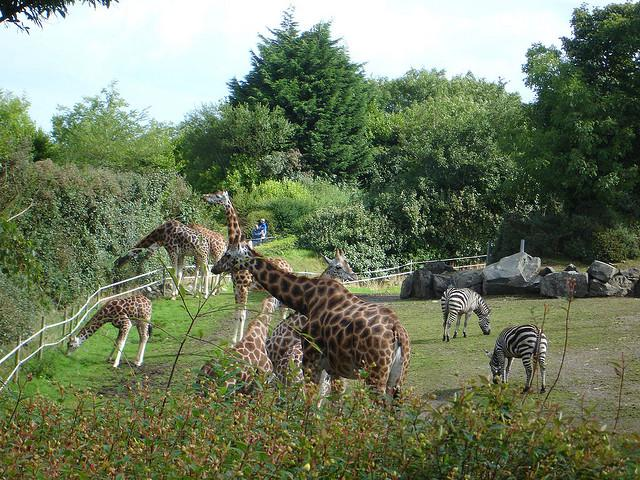How many different species of animals are grazing in the savannah? Please explain your reasoning. two. There are giraffes and zebras. 